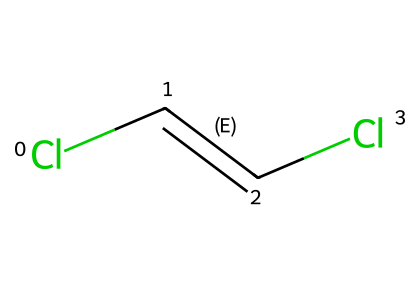What is the molecular formula of trans-dichloroethene? The molecular formula can be derived from counting the atoms in the structure represented by the SMILES notation. The structure indicates there are two carbon atoms, two chlorine atoms, and two hydrogen atoms, leading to the formula C2H2Cl2.
Answer: C2H2Cl2 How many bonds are present in trans-dichloroethene? The chemical structure shows a double bond between the two carbon atoms (C=C) and two single bonds from each carbon to a chlorine atom (C-Cl). Thus, there are a total of 3 bonds (1 double bond + 2 single bonds).
Answer: 3 What type of isomerism is exhibited by trans-dichloroethene? Trans-dichloroethene exhibits geometric isomerism, which arises from the different possible arrangements of atoms or groups in space due to restricted rotation around the double bond. In the trans form, the chlorine atoms are on opposite sides of the double bond.
Answer: geometric isomerism What is the significance of the trans configuration in trans-dichloroethene? The trans configuration reduces steric hindrance and may influence physical properties such as boiling point and polarity compared to its cis counterpart where chlorine atoms are on the same side. This impacts its reactivity and solvent properties in cleaning applications.
Answer: reduces steric hindrance What are the potential applications of trans-dichloroethene in PCB cleaning solvents? In PCB cleaning, trans-dichloroethene’s non-polar characteristics can help dissolve oils and other contaminants effectively, making it suitable for cleaning electronic devices without causing damage.
Answer: PCB cleaning How do the properties of trans-dichloroethene compare to cis-dichloroethene? The two isomers have different physical properties, such as polarity and boiling points. Trans-dichloroethene is typically less polar than cis-dichloroethene due to the spatial arrangement of the chlorine atoms contributing to differences in intermolecular forces.
Answer: different physical properties What aspect of its structure allows trans-dichloroethene to act as a solvent? The presence of two chlorine atoms enhances its polarity while the non-polar hydrocarbon backbone allows it to dissolve both polar and non-polar substances, making it versatile as a cleaning solvent for various applications.
Answer: versatility as a solvent 